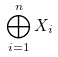Convert formula to latex. <formula><loc_0><loc_0><loc_500><loc_500>\bigoplus _ { i = 1 } ^ { n } X _ { i }</formula> 